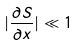<formula> <loc_0><loc_0><loc_500><loc_500>| \frac { \partial S } { \partial x } | \ll 1</formula> 